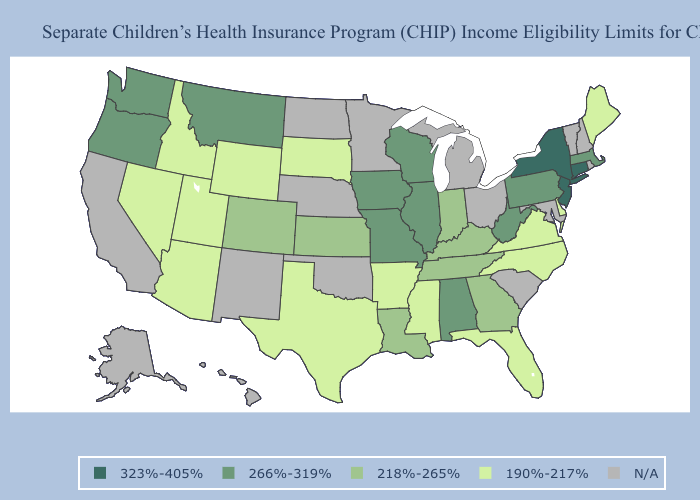What is the highest value in the South ?
Answer briefly. 266%-319%. What is the highest value in states that border Oklahoma?
Be succinct. 266%-319%. Name the states that have a value in the range 190%-217%?
Be succinct. Arizona, Arkansas, Delaware, Florida, Idaho, Maine, Mississippi, Nevada, North Carolina, South Dakota, Texas, Utah, Virginia, Wyoming. What is the lowest value in the MidWest?
Answer briefly. 190%-217%. How many symbols are there in the legend?
Concise answer only. 5. Which states have the lowest value in the Northeast?
Short answer required. Maine. Name the states that have a value in the range 190%-217%?
Be succinct. Arizona, Arkansas, Delaware, Florida, Idaho, Maine, Mississippi, Nevada, North Carolina, South Dakota, Texas, Utah, Virginia, Wyoming. Does the map have missing data?
Write a very short answer. Yes. Does the map have missing data?
Keep it brief. Yes. Name the states that have a value in the range N/A?
Write a very short answer. Alaska, California, Hawaii, Maryland, Michigan, Minnesota, Nebraska, New Hampshire, New Mexico, North Dakota, Ohio, Oklahoma, Rhode Island, South Carolina, Vermont. What is the value of Alabama?
Concise answer only. 266%-319%. Does Montana have the highest value in the USA?
Concise answer only. No. Which states hav the highest value in the Northeast?
Short answer required. Connecticut, New Jersey, New York. 